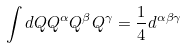Convert formula to latex. <formula><loc_0><loc_0><loc_500><loc_500>\int d Q Q ^ { \alpha } Q ^ { \beta } Q ^ { \gamma } = \frac { 1 } { 4 } d ^ { \alpha \beta \gamma }</formula> 